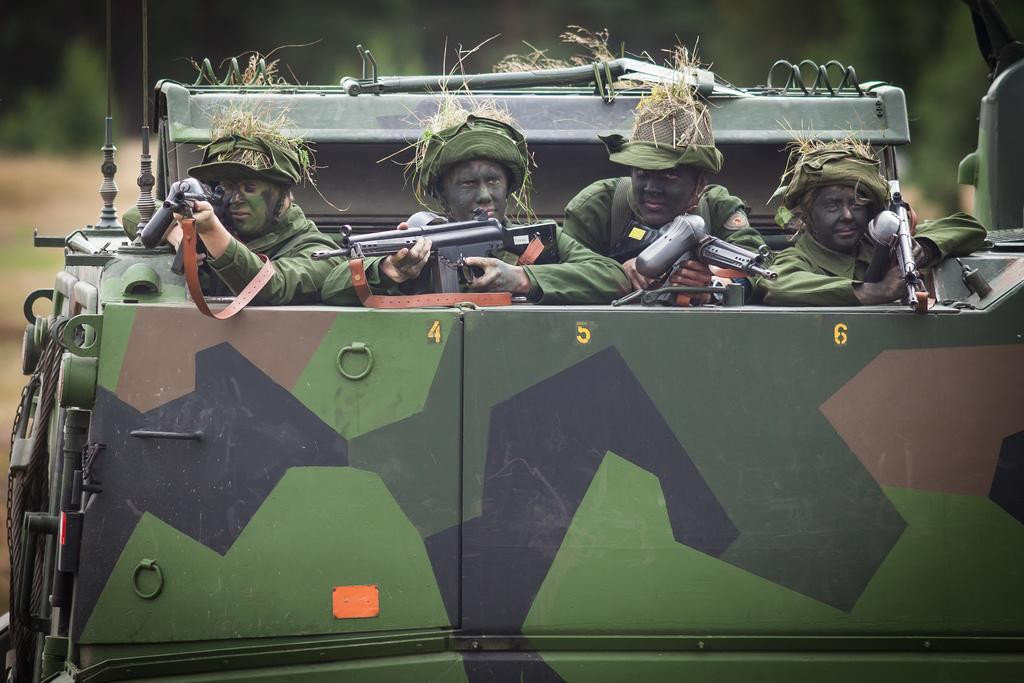How many people are in the image? There are four persons in the image. What are the people doing in the image? The people are on a vehicle and holding guns. Can you describe the background of the image? The background of the image is blurred. What is the title of the movie that the people are acting in, as seen in the image? There is no movie or title mentioned in the image; it is a still photograph of four people on a vehicle holding guns. 